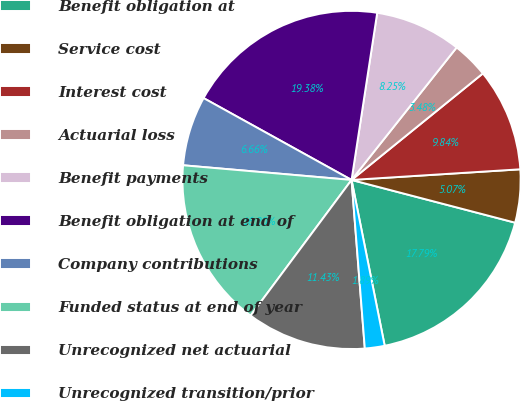Convert chart. <chart><loc_0><loc_0><loc_500><loc_500><pie_chart><fcel>Benefit obligation at<fcel>Service cost<fcel>Interest cost<fcel>Actuarial loss<fcel>Benefit payments<fcel>Benefit obligation at end of<fcel>Company contributions<fcel>Funded status at end of year<fcel>Unrecognized net actuarial<fcel>Unrecognized transition/prior<nl><fcel>17.79%<fcel>5.07%<fcel>9.84%<fcel>3.48%<fcel>8.25%<fcel>19.38%<fcel>6.66%<fcel>16.2%<fcel>11.43%<fcel>1.89%<nl></chart> 